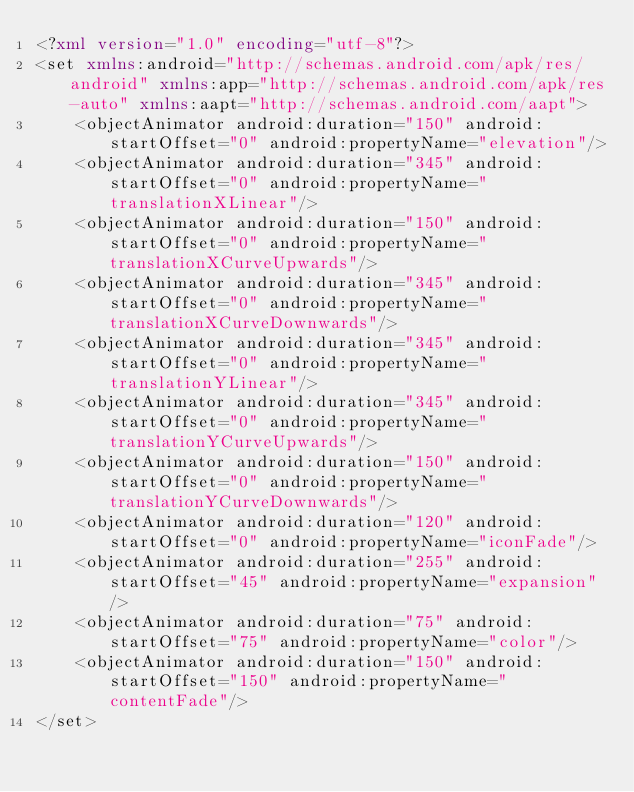<code> <loc_0><loc_0><loc_500><loc_500><_XML_><?xml version="1.0" encoding="utf-8"?>
<set xmlns:android="http://schemas.android.com/apk/res/android" xmlns:app="http://schemas.android.com/apk/res-auto" xmlns:aapt="http://schemas.android.com/aapt">
    <objectAnimator android:duration="150" android:startOffset="0" android:propertyName="elevation"/>
    <objectAnimator android:duration="345" android:startOffset="0" android:propertyName="translationXLinear"/>
    <objectAnimator android:duration="150" android:startOffset="0" android:propertyName="translationXCurveUpwards"/>
    <objectAnimator android:duration="345" android:startOffset="0" android:propertyName="translationXCurveDownwards"/>
    <objectAnimator android:duration="345" android:startOffset="0" android:propertyName="translationYLinear"/>
    <objectAnimator android:duration="345" android:startOffset="0" android:propertyName="translationYCurveUpwards"/>
    <objectAnimator android:duration="150" android:startOffset="0" android:propertyName="translationYCurveDownwards"/>
    <objectAnimator android:duration="120" android:startOffset="0" android:propertyName="iconFade"/>
    <objectAnimator android:duration="255" android:startOffset="45" android:propertyName="expansion"/>
    <objectAnimator android:duration="75" android:startOffset="75" android:propertyName="color"/>
    <objectAnimator android:duration="150" android:startOffset="150" android:propertyName="contentFade"/>
</set>
</code> 